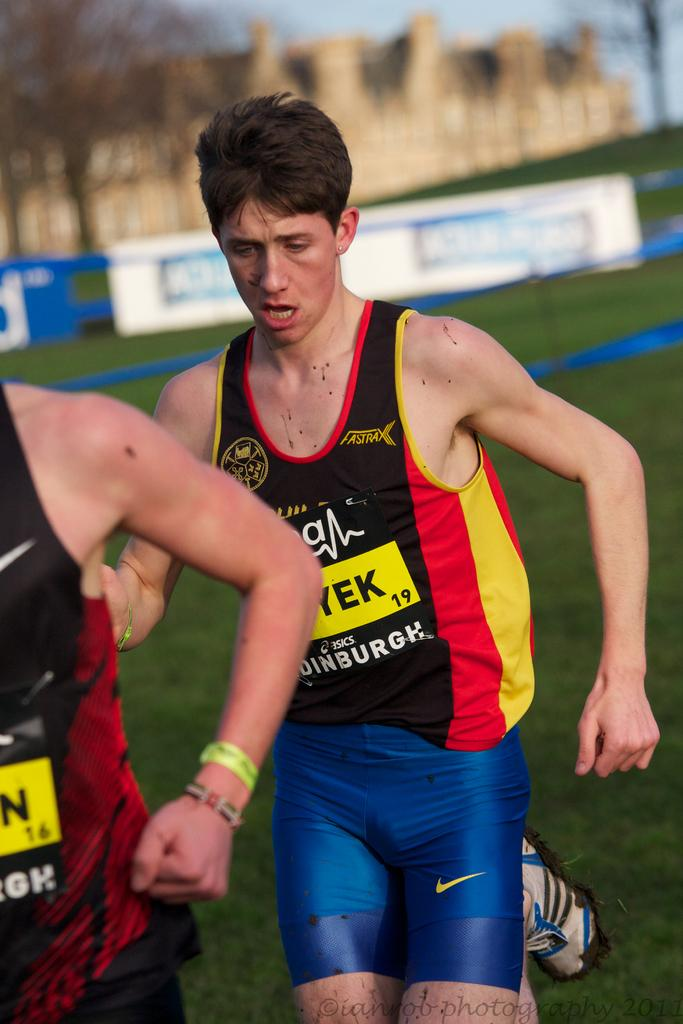<image>
Share a concise interpretation of the image provided. A kid runs while wearing Asics and Fastrax uniform tank top. 